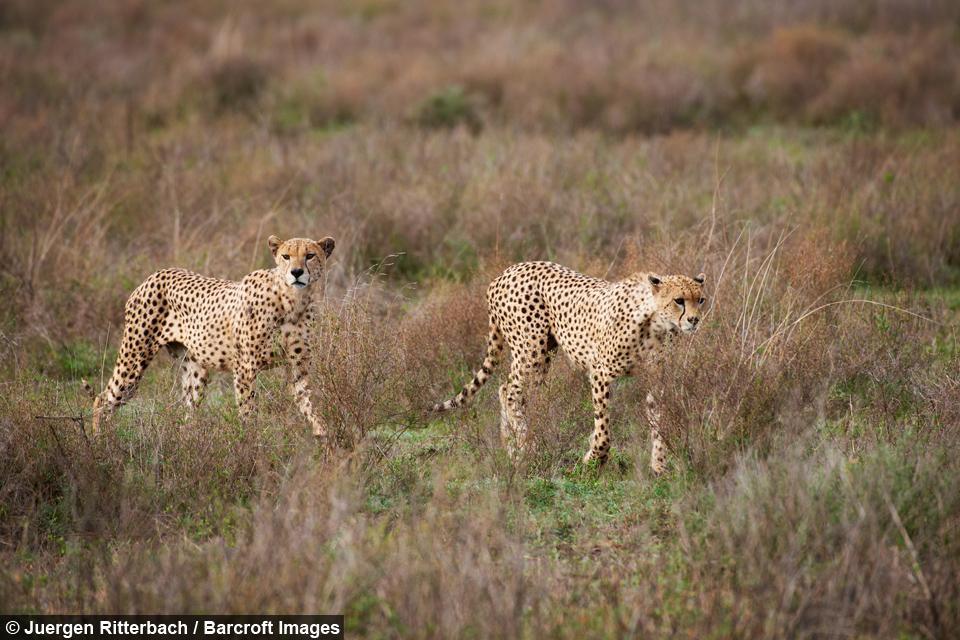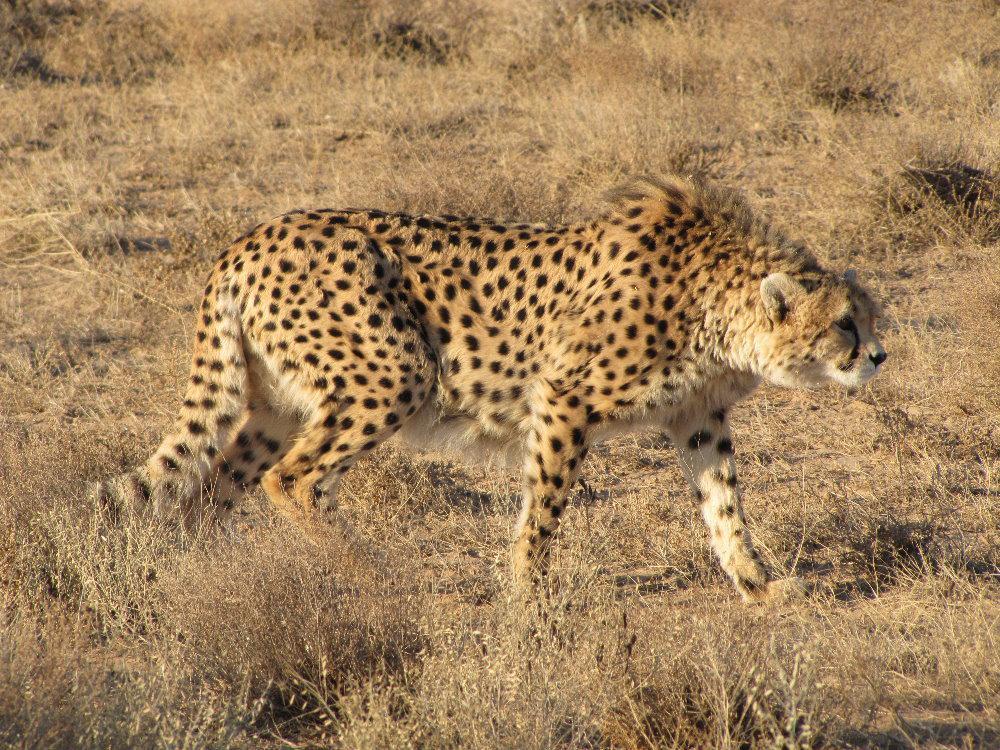The first image is the image on the left, the second image is the image on the right. Given the left and right images, does the statement "In one of the images there is a single leopard running." hold true? Answer yes or no. No. The first image is the image on the left, the second image is the image on the right. Evaluate the accuracy of this statement regarding the images: "There are three total cheetahs.". Is it true? Answer yes or no. Yes. 